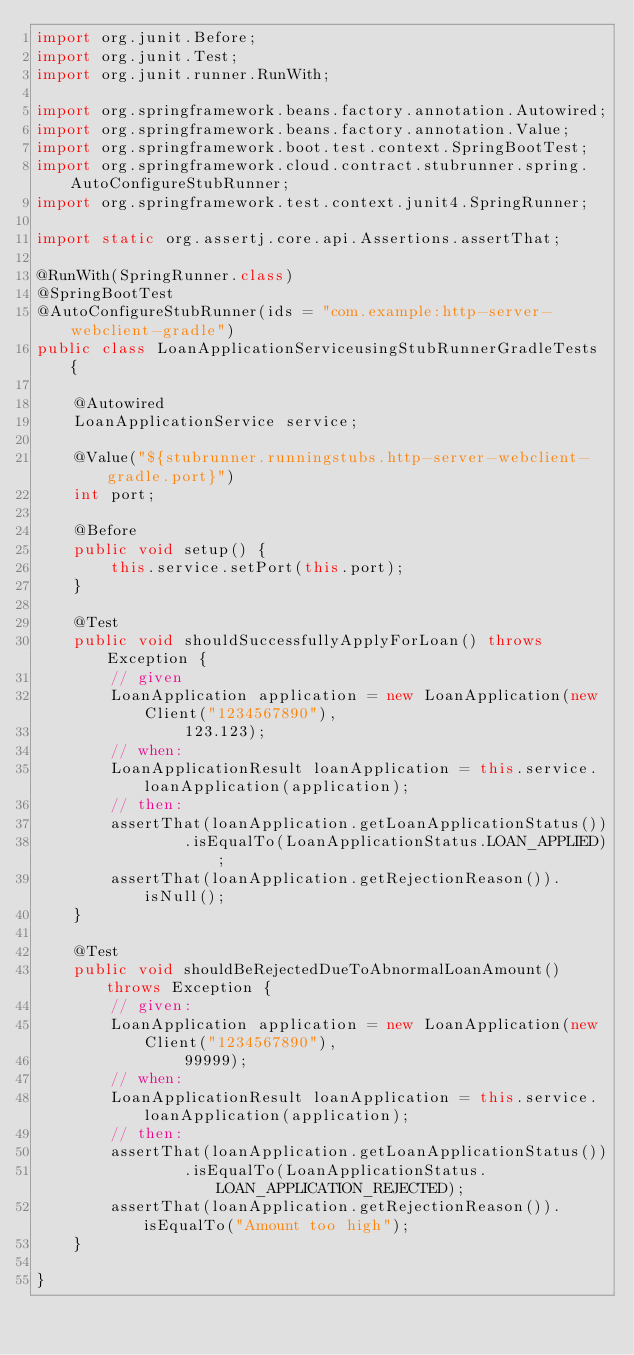Convert code to text. <code><loc_0><loc_0><loc_500><loc_500><_Java_>import org.junit.Before;
import org.junit.Test;
import org.junit.runner.RunWith;

import org.springframework.beans.factory.annotation.Autowired;
import org.springframework.beans.factory.annotation.Value;
import org.springframework.boot.test.context.SpringBootTest;
import org.springframework.cloud.contract.stubrunner.spring.AutoConfigureStubRunner;
import org.springframework.test.context.junit4.SpringRunner;

import static org.assertj.core.api.Assertions.assertThat;

@RunWith(SpringRunner.class)
@SpringBootTest
@AutoConfigureStubRunner(ids = "com.example:http-server-webclient-gradle")
public class LoanApplicationServiceusingStubRunnerGradleTests {

	@Autowired
	LoanApplicationService service;

	@Value("${stubrunner.runningstubs.http-server-webclient-gradle.port}")
	int port;

	@Before
	public void setup() {
		this.service.setPort(this.port);
	}

	@Test
	public void shouldSuccessfullyApplyForLoan() throws Exception {
		// given
		LoanApplication application = new LoanApplication(new Client("1234567890"),
				123.123);
		// when:
		LoanApplicationResult loanApplication = this.service.loanApplication(application);
		// then:
		assertThat(loanApplication.getLoanApplicationStatus())
				.isEqualTo(LoanApplicationStatus.LOAN_APPLIED);
		assertThat(loanApplication.getRejectionReason()).isNull();
	}

	@Test
	public void shouldBeRejectedDueToAbnormalLoanAmount() throws Exception {
		// given:
		LoanApplication application = new LoanApplication(new Client("1234567890"),
				99999);
		// when:
		LoanApplicationResult loanApplication = this.service.loanApplication(application);
		// then:
		assertThat(loanApplication.getLoanApplicationStatus())
				.isEqualTo(LoanApplicationStatus.LOAN_APPLICATION_REJECTED);
		assertThat(loanApplication.getRejectionReason()).isEqualTo("Amount too high");
	}

}
</code> 